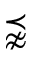Convert formula to latex. <formula><loc_0><loc_0><loc_500><loc_500>\precnapprox</formula> 